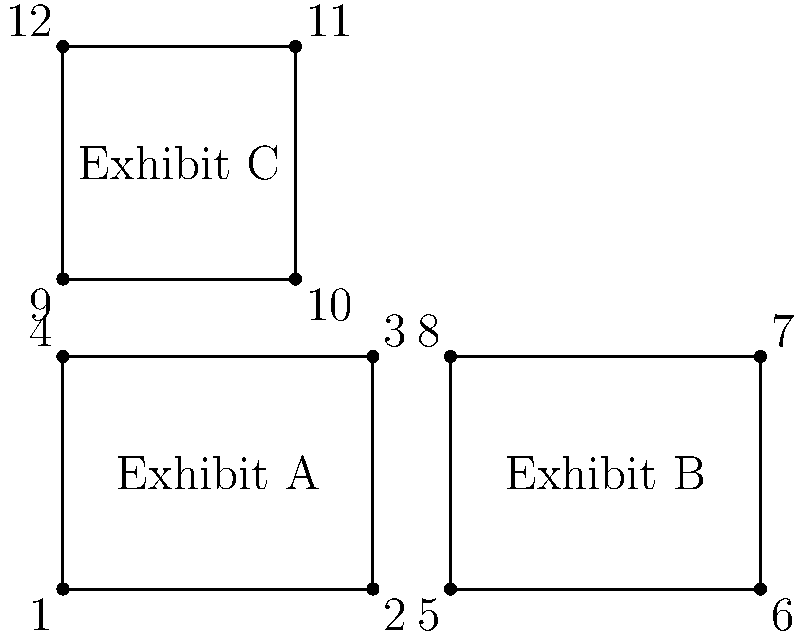In the museum floor plan shown, which exhibit rooms are congruent? Identifying these could help in planning uniform security measures. Select all that apply.

A) Exhibit A and Exhibit B
B) Exhibit A and Exhibit C
C) Exhibit B and Exhibit C
D) All exhibits are congruent To determine which exhibit rooms are congruent, we need to compare their shapes and sizes:

1. First, let's analyze Exhibit A:
   - It's a rectangle with width 4 units and height 3 units.
   - Area = 4 * 3 = 12 square units

2. Now, let's look at Exhibit B:
   - It's also a rectangle with width 4 units and height 3 units.
   - Area = 4 * 3 = 12 square units

3. Finally, let's examine Exhibit C:
   - It's a rectangle with width 3 units and height 3 units.
   - Area = 3 * 3 = 9 square units

4. For shapes to be congruent, they must have the same shape and size.

5. Comparing the exhibits:
   - Exhibit A and Exhibit B have the same dimensions (4x3) and area (12 sq units).
   - Exhibit C has different dimensions (3x3) and a smaller area (9 sq units).

6. Therefore, only Exhibit A and Exhibit B are congruent.

This information is crucial for planning uniform security measures, as congruent rooms can use identical security setups, potentially saving resources and ensuring consistent protection.
Answer: A 